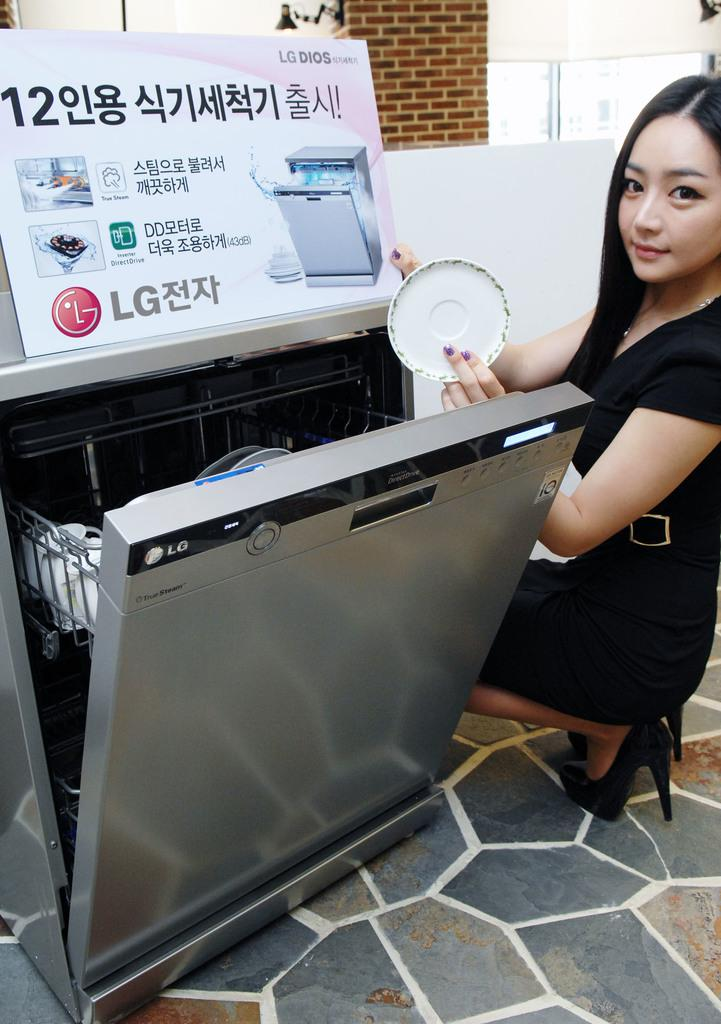Who is the main subject in the image? There is a lady in the image. What is the lady wearing? The lady is wearing a black dress. What is the lady holding in the image? The lady is holding an object. Can you describe any other objects in the image? Yes, there are other objects in the image. What can be seen beneath the lady's feet in the image? The ground is visible in the image. What type of motion is the sun making in the image? There is no sun present in the image, so it cannot be making any motion. What offer is the lady making to the viewer in the image? There is no indication of an offer being made in the image; the lady is simply holding an object. 